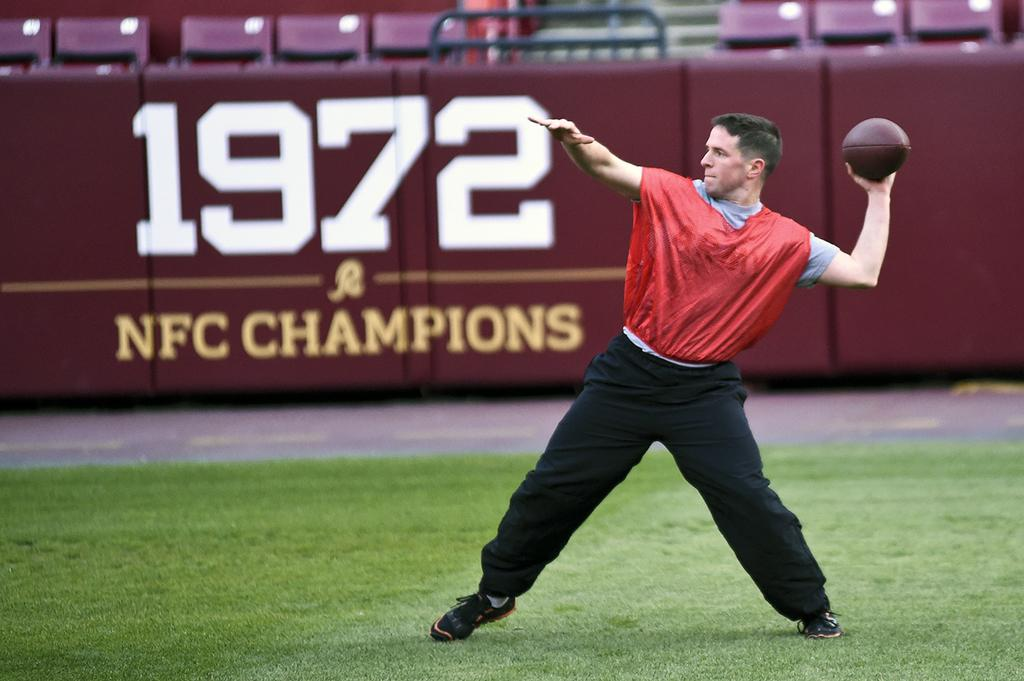What is the man in the image doing? The man is standing on the grass. What is the man holding in the image? The man is holding a rugby ball. What can be seen in the background of the image? There is a wall and chairs in the background of the image. What type of apple is the man eating in the image? There is no apple present in the image; the man is holding a rugby ball. What scientific experiment is the man conducting in the image? There is no scientific experiment being conducted in the image; the man is simply standing on the grass holding a rugby ball. 